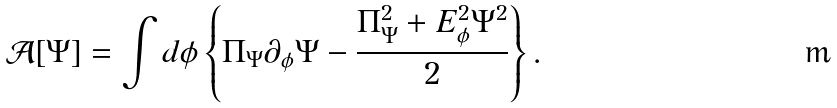<formula> <loc_0><loc_0><loc_500><loc_500>\mathcal { A } [ \Psi ] = \int d \phi \left \{ \Pi _ { \Psi } \partial _ { \phi } \Psi - \frac { \Pi ^ { 2 } _ { \Psi } + E _ { \phi } ^ { 2 } \Psi ^ { 2 } } { 2 } \right \} .</formula> 